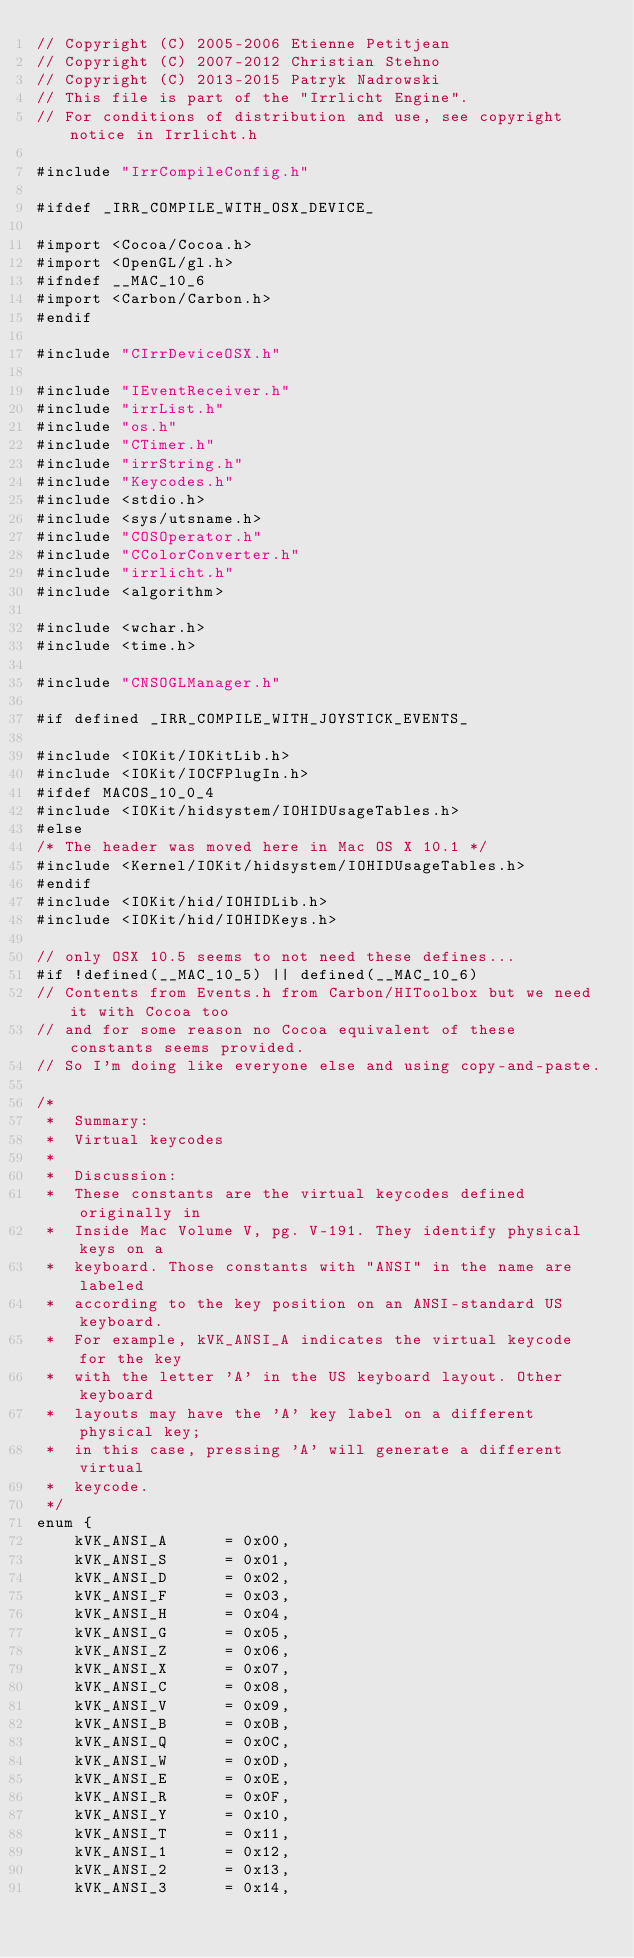Convert code to text. <code><loc_0><loc_0><loc_500><loc_500><_ObjectiveC_>// Copyright (C) 2005-2006 Etienne Petitjean
// Copyright (C) 2007-2012 Christian Stehno
// Copyright (C) 2013-2015 Patryk Nadrowski
// This file is part of the "Irrlicht Engine".
// For conditions of distribution and use, see copyright notice in Irrlicht.h

#include "IrrCompileConfig.h"

#ifdef _IRR_COMPILE_WITH_OSX_DEVICE_

#import <Cocoa/Cocoa.h>
#import <OpenGL/gl.h>
#ifndef __MAC_10_6
#import <Carbon/Carbon.h>
#endif

#include "CIrrDeviceOSX.h"

#include "IEventReceiver.h"
#include "irrList.h"
#include "os.h"
#include "CTimer.h"
#include "irrString.h"
#include "Keycodes.h"
#include <stdio.h>
#include <sys/utsname.h>
#include "COSOperator.h"
#include "CColorConverter.h"
#include "irrlicht.h"
#include <algorithm>

#include <wchar.h>
#include <time.h>

#include "CNSOGLManager.h"

#if defined _IRR_COMPILE_WITH_JOYSTICK_EVENTS_

#include <IOKit/IOKitLib.h>
#include <IOKit/IOCFPlugIn.h>
#ifdef MACOS_10_0_4
#include <IOKit/hidsystem/IOHIDUsageTables.h>
#else
/* The header was moved here in Mac OS X 10.1 */
#include <Kernel/IOKit/hidsystem/IOHIDUsageTables.h>
#endif
#include <IOKit/hid/IOHIDLib.h>
#include <IOKit/hid/IOHIDKeys.h>

// only OSX 10.5 seems to not need these defines...
#if !defined(__MAC_10_5) || defined(__MAC_10_6)
// Contents from Events.h from Carbon/HIToolbox but we need it with Cocoa too
// and for some reason no Cocoa equivalent of these constants seems provided.
// So I'm doing like everyone else and using copy-and-paste.

/*
 *  Summary:
 *	Virtual keycodes
 *
 *  Discussion:
 *	These constants are the virtual keycodes defined originally in
 *	Inside Mac Volume V, pg. V-191. They identify physical keys on a
 *	keyboard. Those constants with "ANSI" in the name are labeled
 *	according to the key position on an ANSI-standard US keyboard.
 *	For example, kVK_ANSI_A indicates the virtual keycode for the key
 *	with the letter 'A' in the US keyboard layout. Other keyboard
 *	layouts may have the 'A' key label on a different physical key;
 *	in this case, pressing 'A' will generate a different virtual
 *	keycode.
 */
enum {
	kVK_ANSI_A		= 0x00,
	kVK_ANSI_S		= 0x01,
	kVK_ANSI_D		= 0x02,
	kVK_ANSI_F		= 0x03,
	kVK_ANSI_H		= 0x04,
	kVK_ANSI_G		= 0x05,
	kVK_ANSI_Z		= 0x06,
	kVK_ANSI_X		= 0x07,
	kVK_ANSI_C		= 0x08,
	kVK_ANSI_V		= 0x09,
	kVK_ANSI_B		= 0x0B,
	kVK_ANSI_Q		= 0x0C,
	kVK_ANSI_W		= 0x0D,
	kVK_ANSI_E		= 0x0E,
	kVK_ANSI_R		= 0x0F,
	kVK_ANSI_Y		= 0x10,
	kVK_ANSI_T		= 0x11,
	kVK_ANSI_1		= 0x12,
	kVK_ANSI_2		= 0x13,
	kVK_ANSI_3		= 0x14,</code> 